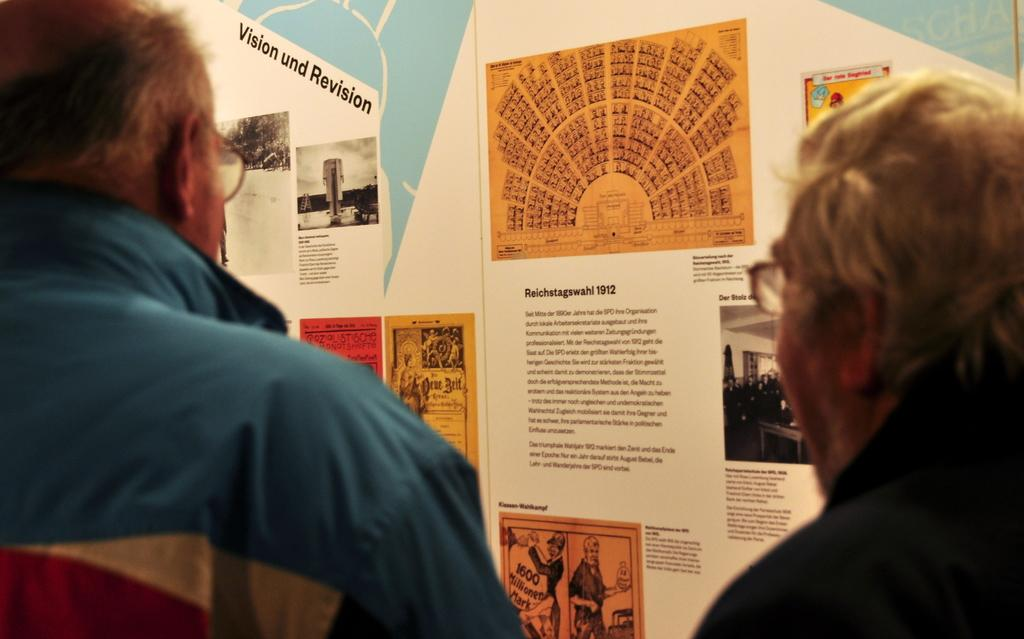How many people are in the image? There are two people in the image. What can be seen in the background of the image? There is a banner in the background of the image. What is written or depicted on the banner? The banner contains text and images. What type of unit is being used to measure the distance between the two people in the image? There is no unit mentioned or implied in the image, as it does not involve any measurements or distances between the two people. 